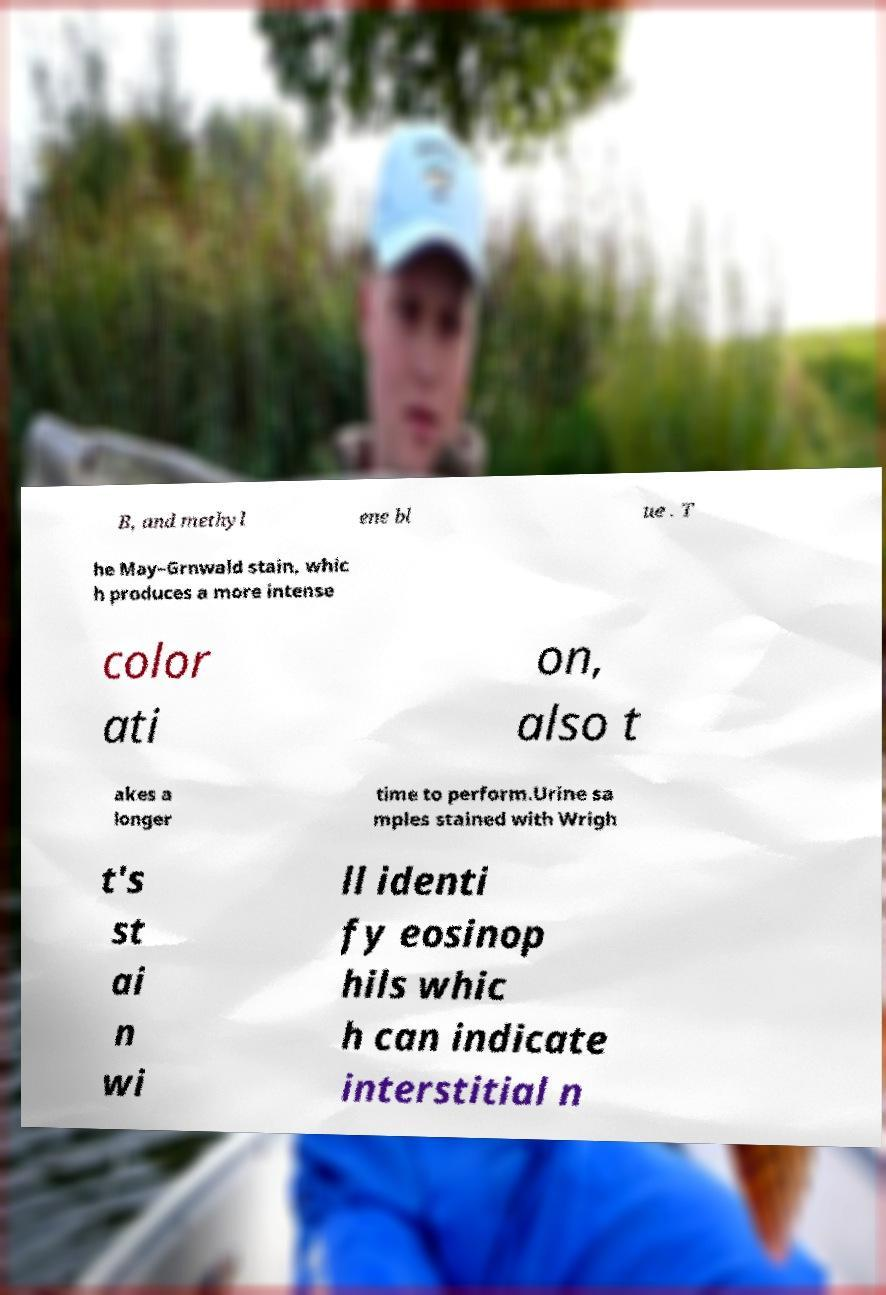There's text embedded in this image that I need extracted. Can you transcribe it verbatim? B, and methyl ene bl ue . T he May–Grnwald stain, whic h produces a more intense color ati on, also t akes a longer time to perform.Urine sa mples stained with Wrigh t's st ai n wi ll identi fy eosinop hils whic h can indicate interstitial n 